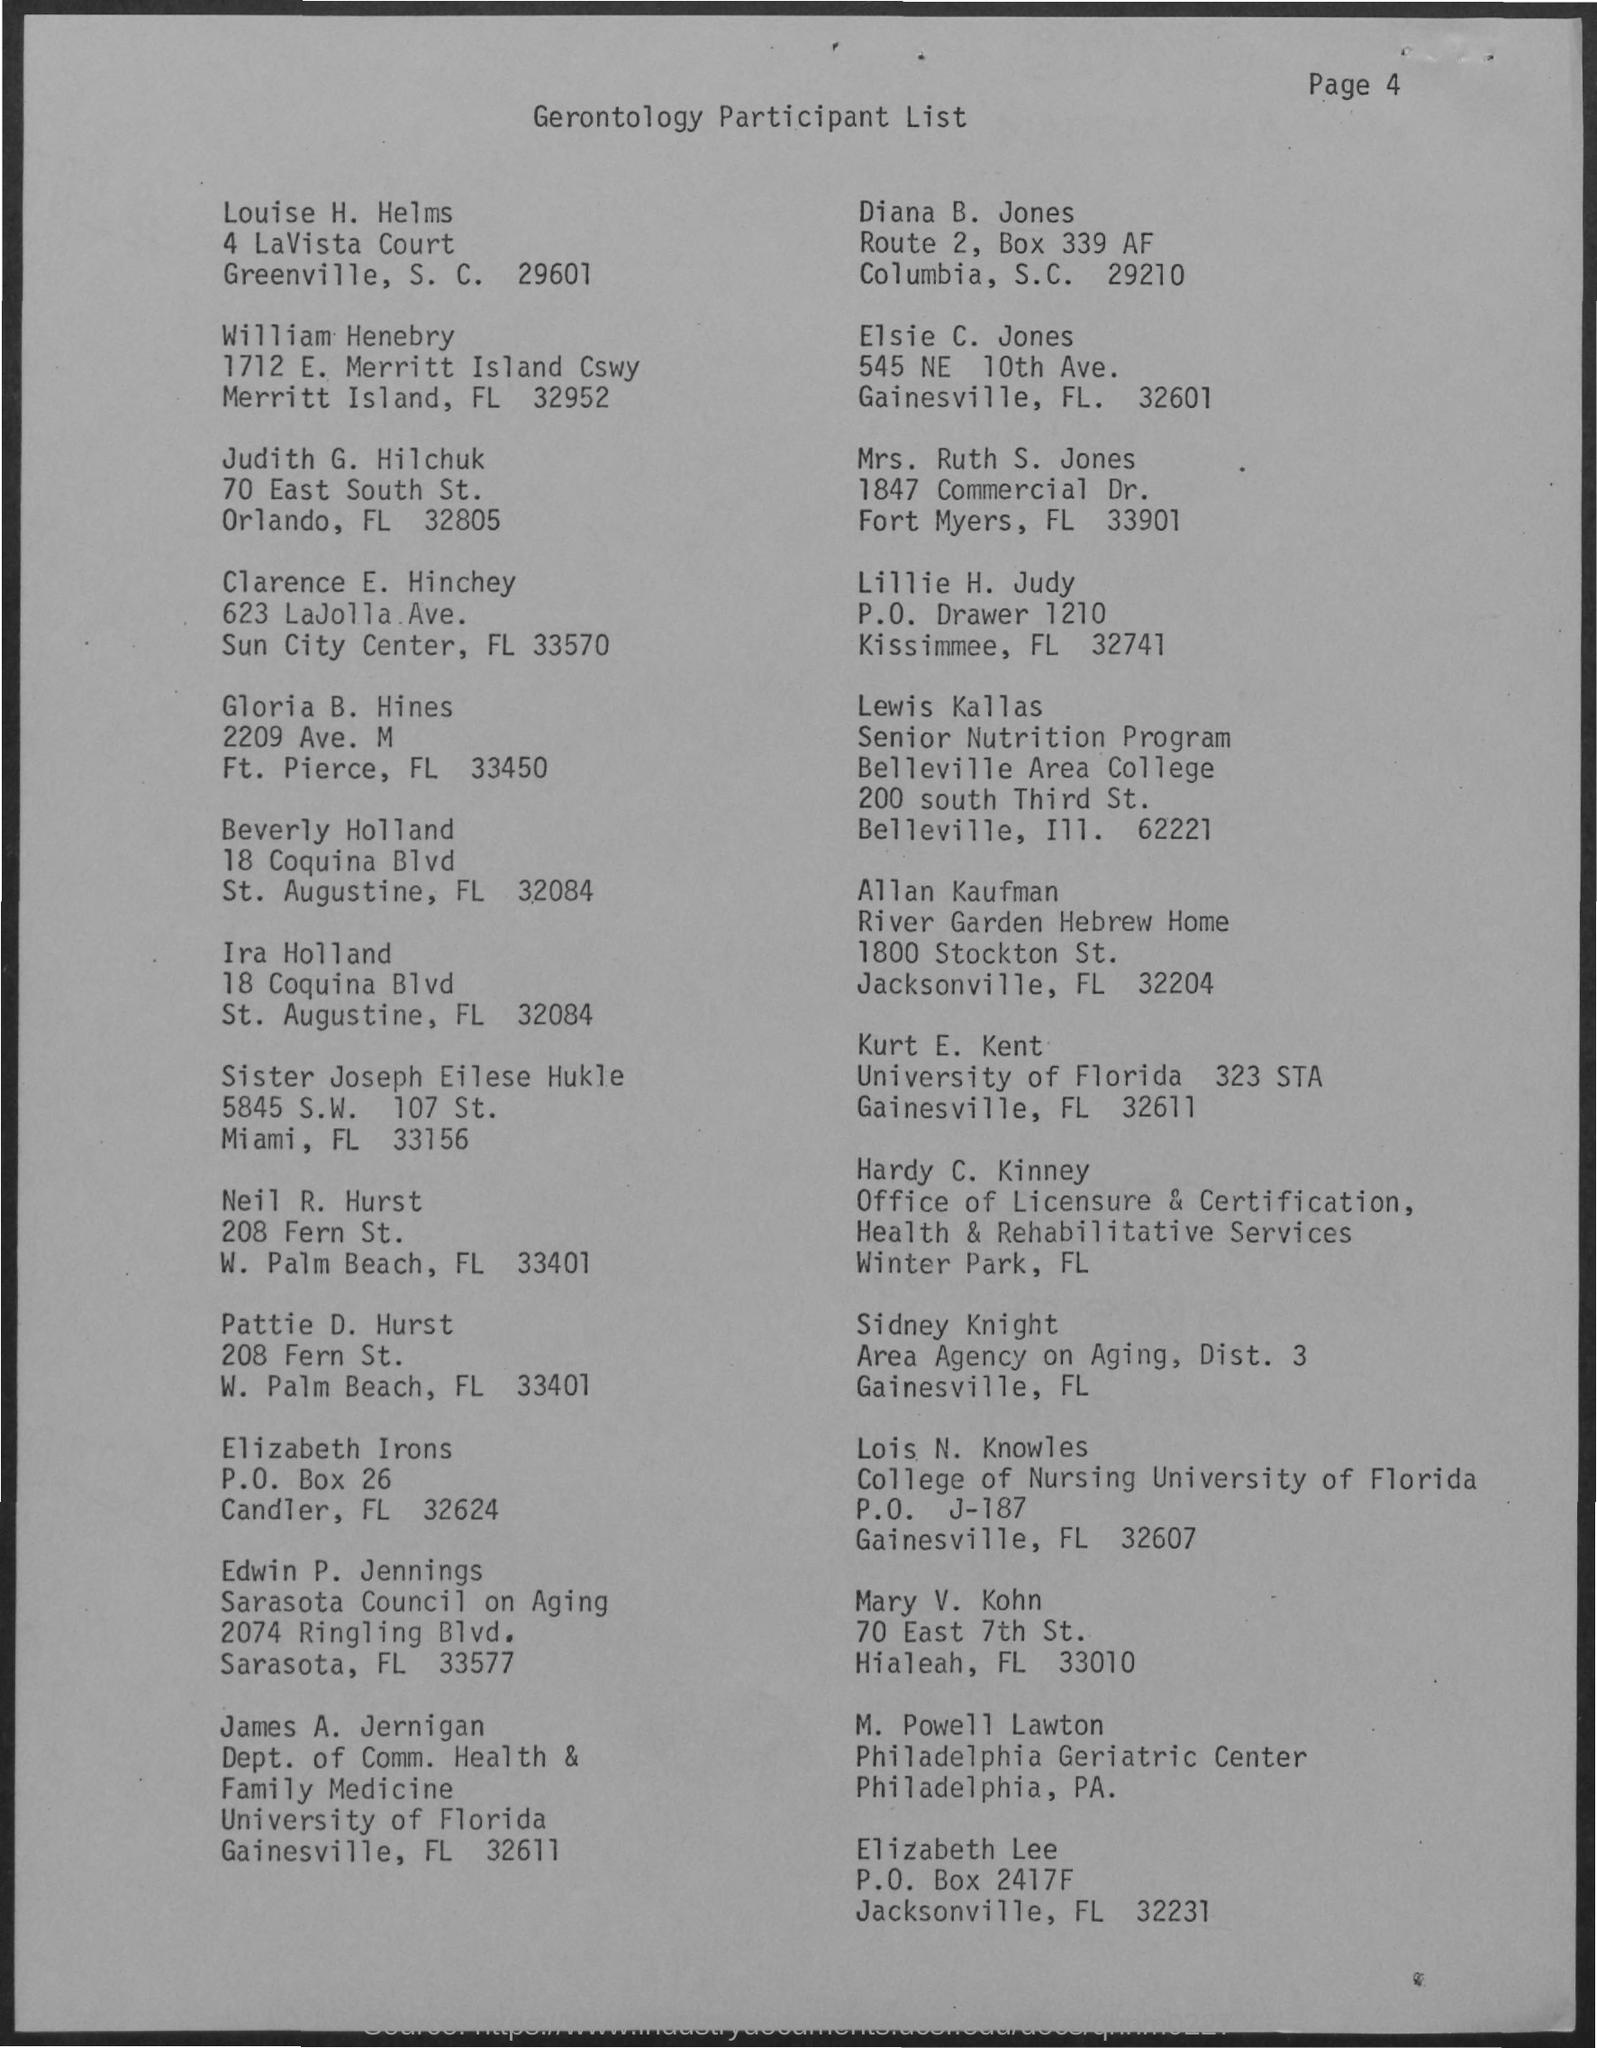What is the title of the document?
Give a very brief answer. Gerontology participant list. What is the Page Number?
Provide a short and direct response. Page 4. 